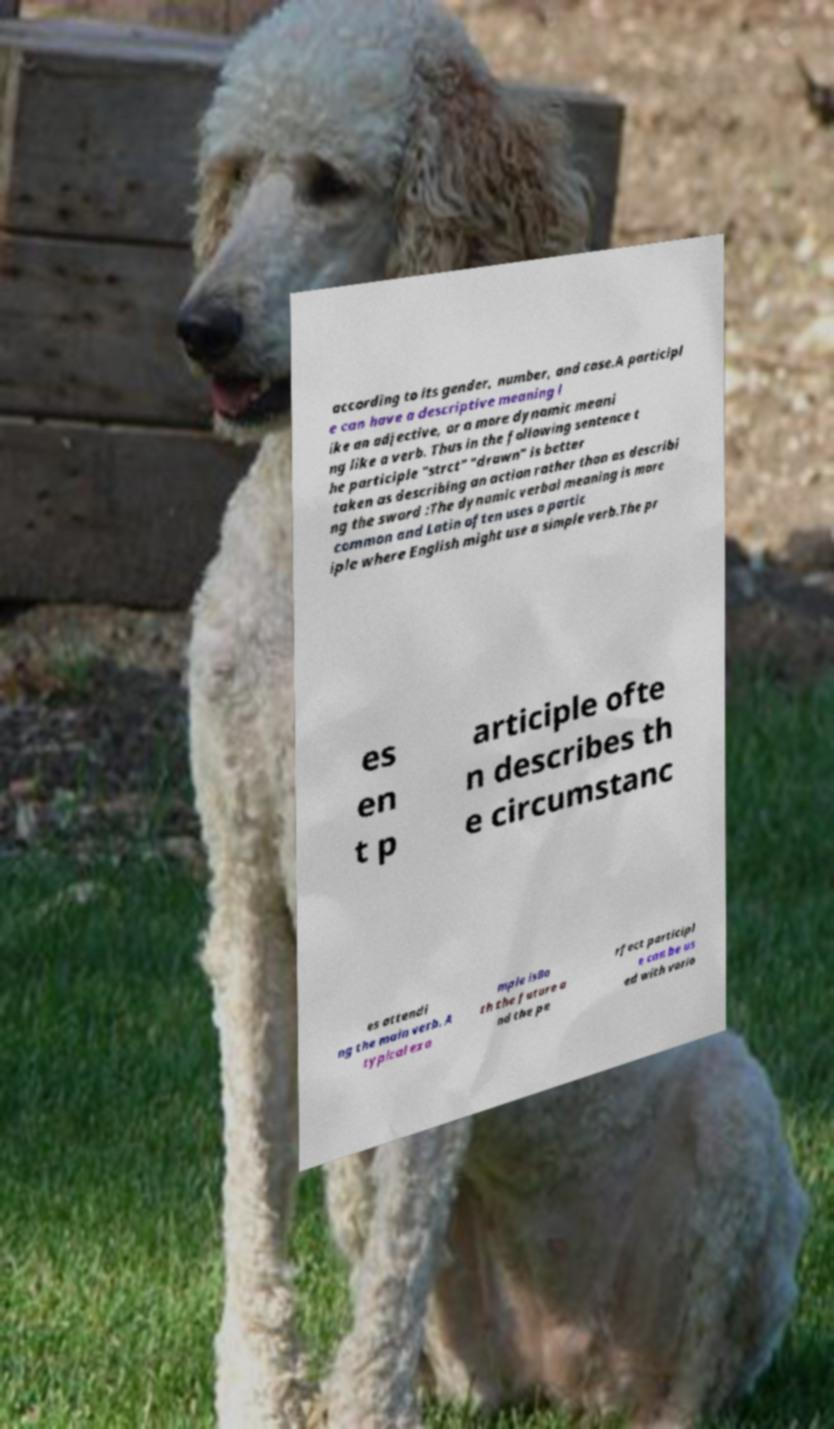Please read and relay the text visible in this image. What does it say? according to its gender, number, and case.A participl e can have a descriptive meaning l ike an adjective, or a more dynamic meani ng like a verb. Thus in the following sentence t he participle "strct" "drawn" is better taken as describing an action rather than as describi ng the sword :The dynamic verbal meaning is more common and Latin often uses a partic iple where English might use a simple verb.The pr es en t p articiple ofte n describes th e circumstanc es attendi ng the main verb. A typical exa mple isBo th the future a nd the pe rfect participl e can be us ed with vario 